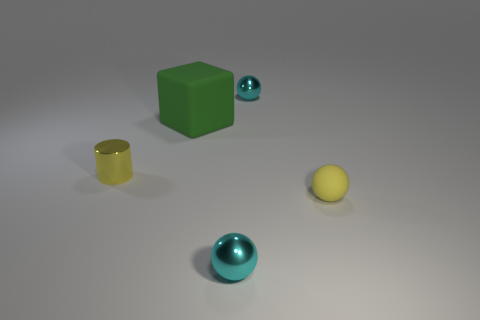Is the large thing the same shape as the yellow shiny thing?
Make the answer very short. No. Does the thing that is on the left side of the green matte cube have the same size as the small yellow matte thing?
Make the answer very short. Yes. What is the size of the metal thing that is both in front of the green object and to the right of the rubber cube?
Provide a short and direct response. Small. There is a tiny cylinder that is the same color as the tiny matte sphere; what is its material?
Your response must be concise. Metal. What number of cubes have the same color as the tiny cylinder?
Offer a very short reply. 0. Are there the same number of green cubes that are left of the yellow cylinder and large green rubber things?
Ensure brevity in your answer.  No. What color is the tiny cylinder?
Make the answer very short. Yellow. There is a green cube that is made of the same material as the tiny yellow ball; what is its size?
Your answer should be very brief. Large. What color is the sphere that is made of the same material as the big block?
Provide a succinct answer. Yellow. Is there a green object that has the same size as the yellow rubber ball?
Provide a short and direct response. No. 